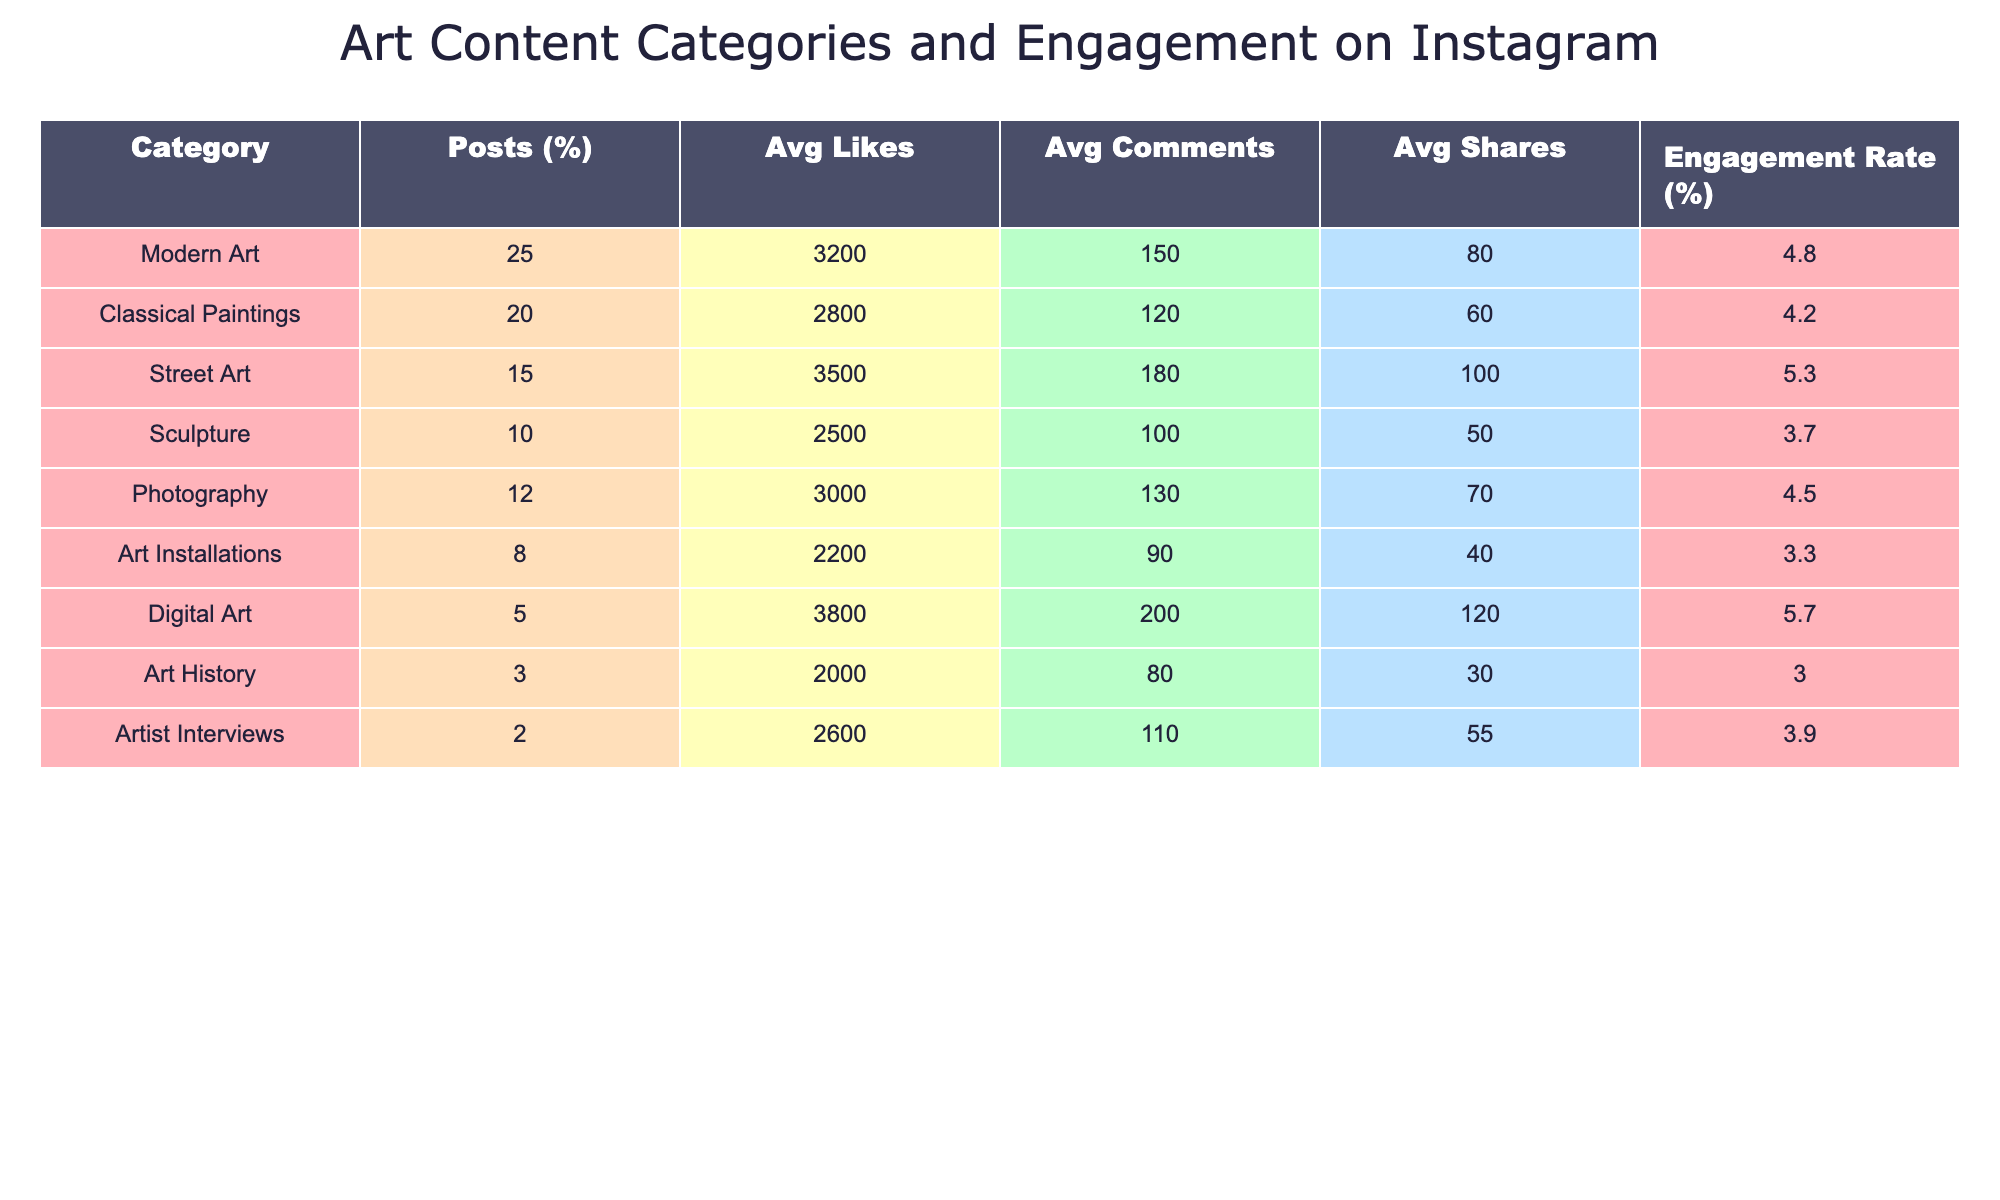What category has the highest engagement rate? The engagement rates for each category are listed in the table, and upon inspection, Digital Art has the highest engagement rate at 5.7%.
Answer: Digital Art Which category has the lowest average likes? By checking the Avg Likes column, we see that Art Installations has the lowest average likes at 2200.
Answer: Art Installations What is the total percentage of posts for Modern Art and Street Art combined? Adding the percentage of posts for Modern Art (25%) and Street Art (15%) gives us a total of 40%.
Answer: 40% Does Sculpture have a higher average number of comments than Classical Paintings? The average comments for Sculpture is 100, while for Classical Paintings it is 120. Therefore, Sculpture does not have a higher number of comments.
Answer: No What is the difference in engagement rates between Digital Art and Art History? Digital Art has an engagement rate of 5.7% and Art History has 3.0%. The difference is 5.7% - 3.0% = 2.7%.
Answer: 2.7% If we add the average likes of Photography and Artist Interviews, what is the total? The average likes for Photography is 3000 and for Artist Interviews is 2600. Summing these gives us 3000 + 2600 = 5600.
Answer: 5600 What percentage of posts are dedicated to categories other than Modern Art? Modern Art comprises 25% of total posts, so the percentage for other categories is 100% - 25% = 75%.
Answer: 75% Which category has the second highest average shares? The category with the highest average shares is Digital Art (120), followed by Street Art (100). Thus, Street Art has the second highest average shares.
Answer: Street Art What is the average engagement rate for categories that have more than 10% of posts? The categories with more than 10% of posts are Modern Art, Classical Paintings, Street Art, and Photography. Their engagement rates are 4.8%, 4.2%, 5.3%, and 4.5%, respectively. The average is (4.8 + 4.2 + 5.3 + 4.5) / 4 = 4.45%.
Answer: 4.45% Is the average number of shares in Digital Art greater than the average number of shares in Street Art? The average number of shares for Digital Art is 120, while for Street Art it is 100. Thus, Digital Art does have a greater number of shares.
Answer: Yes 